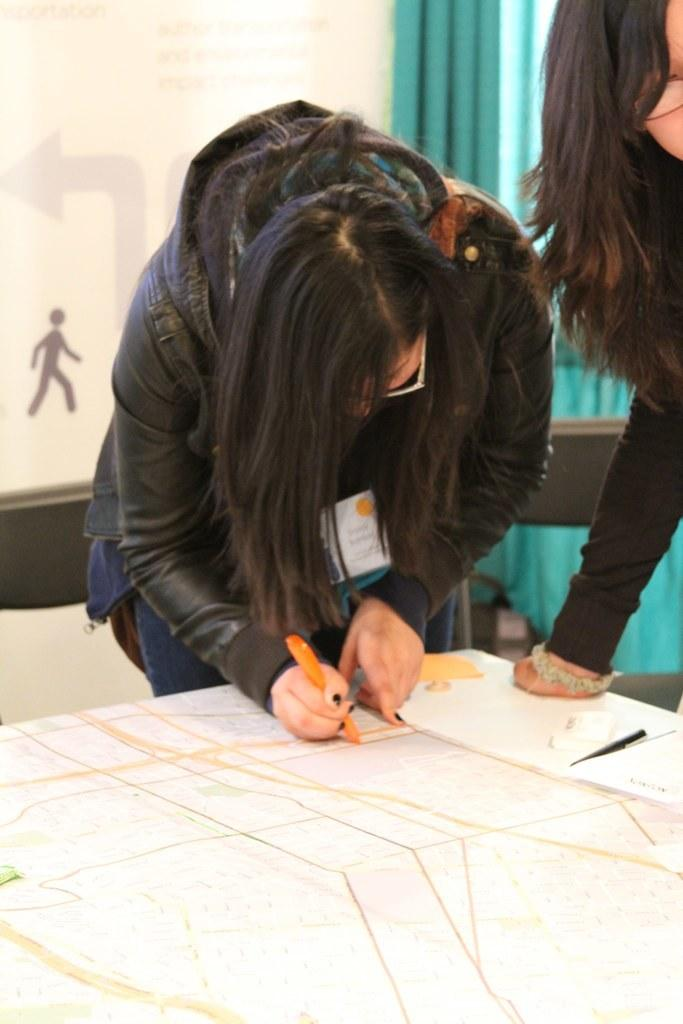How many women are in the image? There are two women in the image. What are the women wearing? Both women are wearing spectacles. What are the women doing in the image? The women are standing. What is in front of the women? There is a table in front of the women. What is on the table? There is a paper and pens on the table. What can be seen in the background of the image? There is a wall and curtains in the background of the image. What type of polish is the woman applying to her nails in the image? There is no woman applying polish to her nails in the image. Can you provide an example of a button that is visible in the image? There are no buttons visible in the image. 